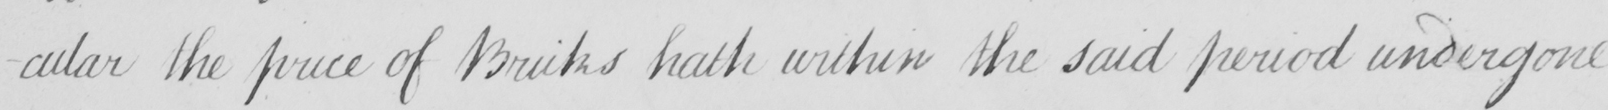What text is written in this handwritten line? -cular the price of Bricks hath within the said period undergone 